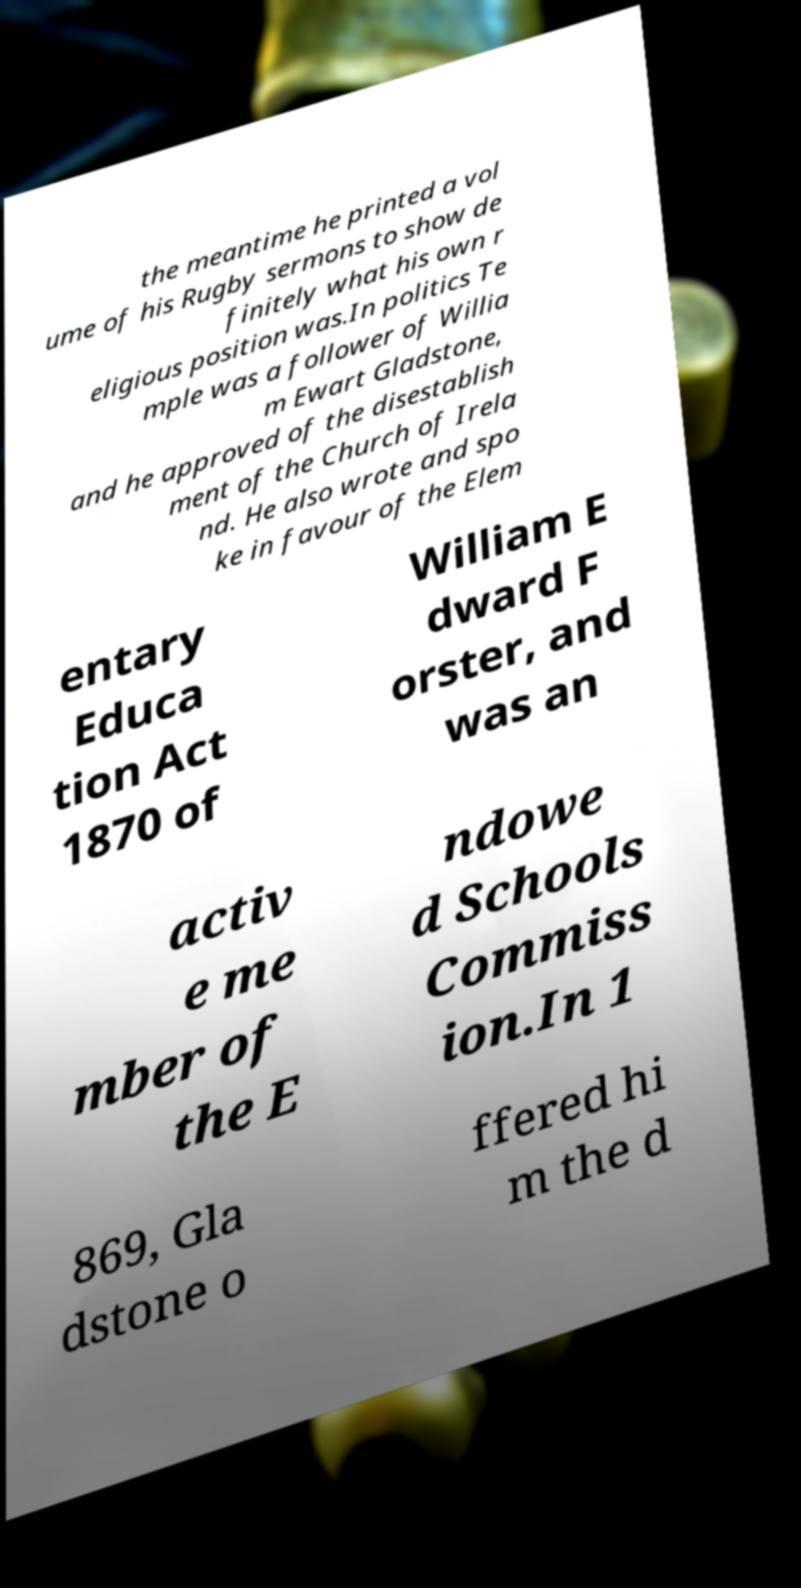Could you assist in decoding the text presented in this image and type it out clearly? the meantime he printed a vol ume of his Rugby sermons to show de finitely what his own r eligious position was.In politics Te mple was a follower of Willia m Ewart Gladstone, and he approved of the disestablish ment of the Church of Irela nd. He also wrote and spo ke in favour of the Elem entary Educa tion Act 1870 of William E dward F orster, and was an activ e me mber of the E ndowe d Schools Commiss ion.In 1 869, Gla dstone o ffered hi m the d 